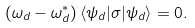Convert formula to latex. <formula><loc_0><loc_0><loc_500><loc_500>( \omega _ { d } - \omega _ { d } ^ { * } ) \, \langle \psi _ { d } | \sigma | \psi _ { d } \rangle = 0 .</formula> 